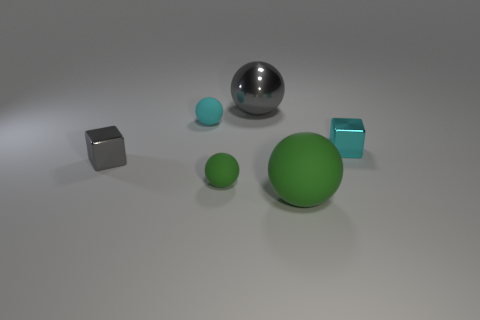Subtract all red cubes. Subtract all red cylinders. How many cubes are left? 2 Add 2 large green things. How many objects exist? 8 Subtract all spheres. How many objects are left? 2 Subtract all big rubber things. Subtract all tiny purple shiny cubes. How many objects are left? 5 Add 4 large matte balls. How many large matte balls are left? 5 Add 3 big shiny spheres. How many big shiny spheres exist? 4 Subtract 0 blue cubes. How many objects are left? 6 